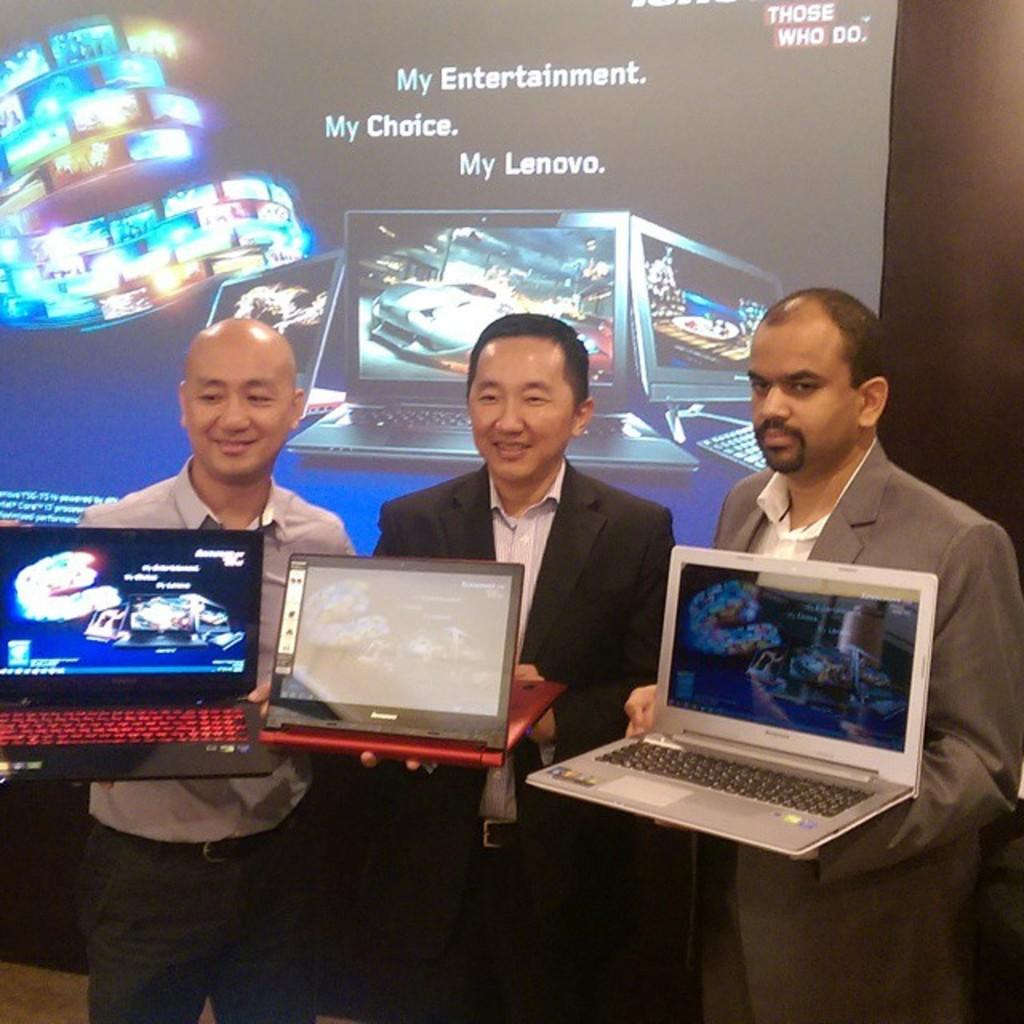How many people are in the image? There are three people in the image. What are the people wearing? The people are wearing different color dresses. What are the people holding in the image? The people are holding laptops. What can be seen in the background of the image? There is a screen visible in the background of the image. What is the connection between the people and the screen in the image? There is no direct connection between the people and the screen in the image; they are simply in the same space. 